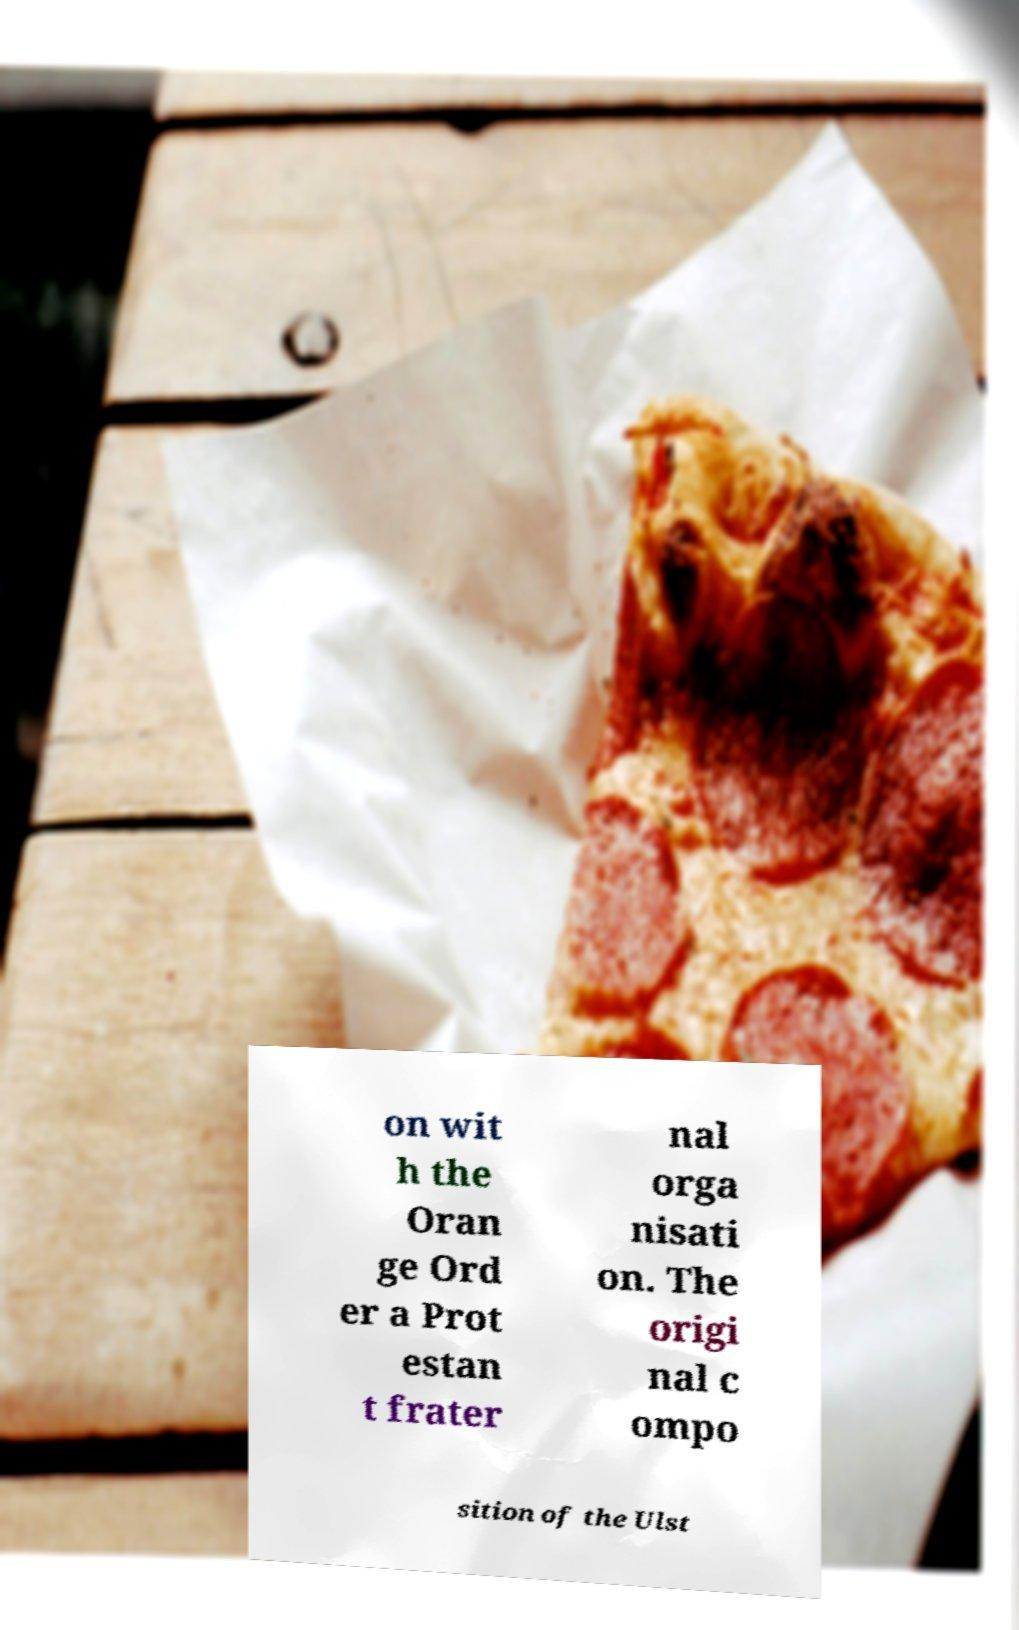Can you accurately transcribe the text from the provided image for me? on wit h the Oran ge Ord er a Prot estan t frater nal orga nisati on. The origi nal c ompo sition of the Ulst 